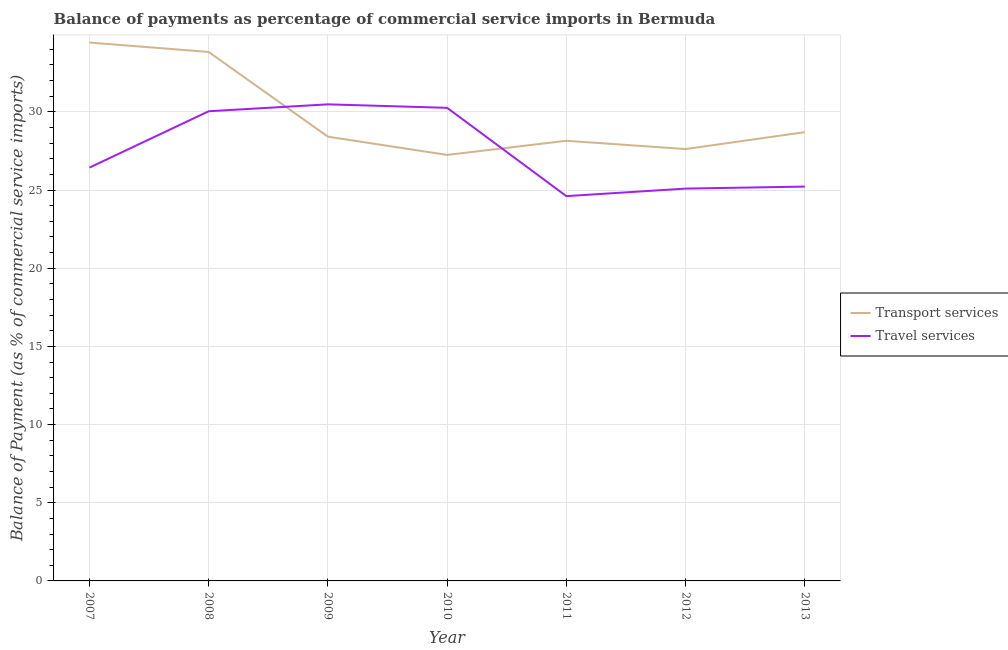What is the balance of payments of transport services in 2008?
Provide a short and direct response. 33.83. Across all years, what is the maximum balance of payments of travel services?
Ensure brevity in your answer.  30.48. Across all years, what is the minimum balance of payments of travel services?
Give a very brief answer. 24.61. In which year was the balance of payments of travel services maximum?
Offer a terse response. 2009. In which year was the balance of payments of transport services minimum?
Provide a short and direct response. 2010. What is the total balance of payments of transport services in the graph?
Provide a short and direct response. 208.41. What is the difference between the balance of payments of travel services in 2007 and that in 2012?
Your response must be concise. 1.34. What is the difference between the balance of payments of travel services in 2010 and the balance of payments of transport services in 2011?
Your answer should be very brief. 2.11. What is the average balance of payments of transport services per year?
Offer a very short reply. 29.77. In the year 2011, what is the difference between the balance of payments of transport services and balance of payments of travel services?
Your answer should be compact. 3.54. What is the ratio of the balance of payments of travel services in 2008 to that in 2009?
Your answer should be compact. 0.99. What is the difference between the highest and the second highest balance of payments of transport services?
Provide a succinct answer. 0.6. What is the difference between the highest and the lowest balance of payments of transport services?
Provide a short and direct response. 7.19. In how many years, is the balance of payments of travel services greater than the average balance of payments of travel services taken over all years?
Provide a succinct answer. 3. Does the balance of payments of travel services monotonically increase over the years?
Make the answer very short. No. What is the difference between two consecutive major ticks on the Y-axis?
Your answer should be compact. 5. Are the values on the major ticks of Y-axis written in scientific E-notation?
Offer a very short reply. No. Does the graph contain any zero values?
Make the answer very short. No. What is the title of the graph?
Provide a succinct answer. Balance of payments as percentage of commercial service imports in Bermuda. Does "Passenger Transport Items" appear as one of the legend labels in the graph?
Ensure brevity in your answer.  No. What is the label or title of the Y-axis?
Provide a short and direct response. Balance of Payment (as % of commercial service imports). What is the Balance of Payment (as % of commercial service imports) in Transport services in 2007?
Your answer should be very brief. 34.44. What is the Balance of Payment (as % of commercial service imports) of Travel services in 2007?
Offer a very short reply. 26.44. What is the Balance of Payment (as % of commercial service imports) of Transport services in 2008?
Your answer should be compact. 33.83. What is the Balance of Payment (as % of commercial service imports) of Travel services in 2008?
Your answer should be very brief. 30.04. What is the Balance of Payment (as % of commercial service imports) in Transport services in 2009?
Offer a terse response. 28.41. What is the Balance of Payment (as % of commercial service imports) in Travel services in 2009?
Ensure brevity in your answer.  30.48. What is the Balance of Payment (as % of commercial service imports) in Transport services in 2010?
Keep it short and to the point. 27.25. What is the Balance of Payment (as % of commercial service imports) in Travel services in 2010?
Provide a short and direct response. 30.26. What is the Balance of Payment (as % of commercial service imports) in Transport services in 2011?
Keep it short and to the point. 28.15. What is the Balance of Payment (as % of commercial service imports) in Travel services in 2011?
Your answer should be very brief. 24.61. What is the Balance of Payment (as % of commercial service imports) in Transport services in 2012?
Provide a short and direct response. 27.62. What is the Balance of Payment (as % of commercial service imports) in Travel services in 2012?
Make the answer very short. 25.09. What is the Balance of Payment (as % of commercial service imports) of Transport services in 2013?
Offer a terse response. 28.7. What is the Balance of Payment (as % of commercial service imports) of Travel services in 2013?
Your answer should be very brief. 25.22. Across all years, what is the maximum Balance of Payment (as % of commercial service imports) of Transport services?
Offer a terse response. 34.44. Across all years, what is the maximum Balance of Payment (as % of commercial service imports) in Travel services?
Offer a terse response. 30.48. Across all years, what is the minimum Balance of Payment (as % of commercial service imports) of Transport services?
Your response must be concise. 27.25. Across all years, what is the minimum Balance of Payment (as % of commercial service imports) in Travel services?
Provide a short and direct response. 24.61. What is the total Balance of Payment (as % of commercial service imports) of Transport services in the graph?
Your answer should be compact. 208.41. What is the total Balance of Payment (as % of commercial service imports) in Travel services in the graph?
Provide a short and direct response. 192.15. What is the difference between the Balance of Payment (as % of commercial service imports) of Transport services in 2007 and that in 2008?
Keep it short and to the point. 0.6. What is the difference between the Balance of Payment (as % of commercial service imports) in Travel services in 2007 and that in 2008?
Make the answer very short. -3.6. What is the difference between the Balance of Payment (as % of commercial service imports) of Transport services in 2007 and that in 2009?
Provide a short and direct response. 6.02. What is the difference between the Balance of Payment (as % of commercial service imports) in Travel services in 2007 and that in 2009?
Provide a succinct answer. -4.05. What is the difference between the Balance of Payment (as % of commercial service imports) in Transport services in 2007 and that in 2010?
Give a very brief answer. 7.19. What is the difference between the Balance of Payment (as % of commercial service imports) in Travel services in 2007 and that in 2010?
Provide a short and direct response. -3.82. What is the difference between the Balance of Payment (as % of commercial service imports) of Transport services in 2007 and that in 2011?
Your response must be concise. 6.28. What is the difference between the Balance of Payment (as % of commercial service imports) in Travel services in 2007 and that in 2011?
Ensure brevity in your answer.  1.82. What is the difference between the Balance of Payment (as % of commercial service imports) in Transport services in 2007 and that in 2012?
Make the answer very short. 6.81. What is the difference between the Balance of Payment (as % of commercial service imports) of Travel services in 2007 and that in 2012?
Your response must be concise. 1.34. What is the difference between the Balance of Payment (as % of commercial service imports) in Transport services in 2007 and that in 2013?
Offer a terse response. 5.73. What is the difference between the Balance of Payment (as % of commercial service imports) of Travel services in 2007 and that in 2013?
Keep it short and to the point. 1.22. What is the difference between the Balance of Payment (as % of commercial service imports) of Transport services in 2008 and that in 2009?
Your response must be concise. 5.42. What is the difference between the Balance of Payment (as % of commercial service imports) of Travel services in 2008 and that in 2009?
Offer a terse response. -0.44. What is the difference between the Balance of Payment (as % of commercial service imports) in Transport services in 2008 and that in 2010?
Offer a very short reply. 6.58. What is the difference between the Balance of Payment (as % of commercial service imports) of Travel services in 2008 and that in 2010?
Your answer should be very brief. -0.22. What is the difference between the Balance of Payment (as % of commercial service imports) of Transport services in 2008 and that in 2011?
Offer a terse response. 5.68. What is the difference between the Balance of Payment (as % of commercial service imports) of Travel services in 2008 and that in 2011?
Ensure brevity in your answer.  5.43. What is the difference between the Balance of Payment (as % of commercial service imports) of Transport services in 2008 and that in 2012?
Make the answer very short. 6.21. What is the difference between the Balance of Payment (as % of commercial service imports) in Travel services in 2008 and that in 2012?
Provide a short and direct response. 4.95. What is the difference between the Balance of Payment (as % of commercial service imports) in Transport services in 2008 and that in 2013?
Provide a succinct answer. 5.13. What is the difference between the Balance of Payment (as % of commercial service imports) in Travel services in 2008 and that in 2013?
Your answer should be compact. 4.82. What is the difference between the Balance of Payment (as % of commercial service imports) in Transport services in 2009 and that in 2010?
Provide a succinct answer. 1.17. What is the difference between the Balance of Payment (as % of commercial service imports) of Travel services in 2009 and that in 2010?
Give a very brief answer. 0.22. What is the difference between the Balance of Payment (as % of commercial service imports) of Transport services in 2009 and that in 2011?
Offer a terse response. 0.26. What is the difference between the Balance of Payment (as % of commercial service imports) of Travel services in 2009 and that in 2011?
Give a very brief answer. 5.87. What is the difference between the Balance of Payment (as % of commercial service imports) in Transport services in 2009 and that in 2012?
Make the answer very short. 0.79. What is the difference between the Balance of Payment (as % of commercial service imports) of Travel services in 2009 and that in 2012?
Offer a very short reply. 5.39. What is the difference between the Balance of Payment (as % of commercial service imports) in Transport services in 2009 and that in 2013?
Your response must be concise. -0.29. What is the difference between the Balance of Payment (as % of commercial service imports) in Travel services in 2009 and that in 2013?
Your answer should be very brief. 5.26. What is the difference between the Balance of Payment (as % of commercial service imports) in Transport services in 2010 and that in 2011?
Ensure brevity in your answer.  -0.9. What is the difference between the Balance of Payment (as % of commercial service imports) of Travel services in 2010 and that in 2011?
Offer a very short reply. 5.65. What is the difference between the Balance of Payment (as % of commercial service imports) in Transport services in 2010 and that in 2012?
Make the answer very short. -0.37. What is the difference between the Balance of Payment (as % of commercial service imports) of Travel services in 2010 and that in 2012?
Your response must be concise. 5.17. What is the difference between the Balance of Payment (as % of commercial service imports) of Transport services in 2010 and that in 2013?
Offer a terse response. -1.45. What is the difference between the Balance of Payment (as % of commercial service imports) of Travel services in 2010 and that in 2013?
Offer a terse response. 5.04. What is the difference between the Balance of Payment (as % of commercial service imports) of Transport services in 2011 and that in 2012?
Give a very brief answer. 0.53. What is the difference between the Balance of Payment (as % of commercial service imports) of Travel services in 2011 and that in 2012?
Make the answer very short. -0.48. What is the difference between the Balance of Payment (as % of commercial service imports) in Transport services in 2011 and that in 2013?
Ensure brevity in your answer.  -0.55. What is the difference between the Balance of Payment (as % of commercial service imports) in Travel services in 2011 and that in 2013?
Your answer should be very brief. -0.61. What is the difference between the Balance of Payment (as % of commercial service imports) of Transport services in 2012 and that in 2013?
Your answer should be compact. -1.08. What is the difference between the Balance of Payment (as % of commercial service imports) of Travel services in 2012 and that in 2013?
Offer a terse response. -0.13. What is the difference between the Balance of Payment (as % of commercial service imports) in Transport services in 2007 and the Balance of Payment (as % of commercial service imports) in Travel services in 2008?
Your response must be concise. 4.39. What is the difference between the Balance of Payment (as % of commercial service imports) in Transport services in 2007 and the Balance of Payment (as % of commercial service imports) in Travel services in 2009?
Ensure brevity in your answer.  3.95. What is the difference between the Balance of Payment (as % of commercial service imports) in Transport services in 2007 and the Balance of Payment (as % of commercial service imports) in Travel services in 2010?
Offer a terse response. 4.17. What is the difference between the Balance of Payment (as % of commercial service imports) in Transport services in 2007 and the Balance of Payment (as % of commercial service imports) in Travel services in 2011?
Provide a succinct answer. 9.82. What is the difference between the Balance of Payment (as % of commercial service imports) of Transport services in 2007 and the Balance of Payment (as % of commercial service imports) of Travel services in 2012?
Offer a terse response. 9.34. What is the difference between the Balance of Payment (as % of commercial service imports) of Transport services in 2007 and the Balance of Payment (as % of commercial service imports) of Travel services in 2013?
Make the answer very short. 9.21. What is the difference between the Balance of Payment (as % of commercial service imports) in Transport services in 2008 and the Balance of Payment (as % of commercial service imports) in Travel services in 2009?
Provide a short and direct response. 3.35. What is the difference between the Balance of Payment (as % of commercial service imports) in Transport services in 2008 and the Balance of Payment (as % of commercial service imports) in Travel services in 2010?
Make the answer very short. 3.57. What is the difference between the Balance of Payment (as % of commercial service imports) of Transport services in 2008 and the Balance of Payment (as % of commercial service imports) of Travel services in 2011?
Offer a terse response. 9.22. What is the difference between the Balance of Payment (as % of commercial service imports) of Transport services in 2008 and the Balance of Payment (as % of commercial service imports) of Travel services in 2012?
Ensure brevity in your answer.  8.74. What is the difference between the Balance of Payment (as % of commercial service imports) in Transport services in 2008 and the Balance of Payment (as % of commercial service imports) in Travel services in 2013?
Your answer should be very brief. 8.61. What is the difference between the Balance of Payment (as % of commercial service imports) in Transport services in 2009 and the Balance of Payment (as % of commercial service imports) in Travel services in 2010?
Offer a very short reply. -1.85. What is the difference between the Balance of Payment (as % of commercial service imports) of Transport services in 2009 and the Balance of Payment (as % of commercial service imports) of Travel services in 2011?
Make the answer very short. 3.8. What is the difference between the Balance of Payment (as % of commercial service imports) of Transport services in 2009 and the Balance of Payment (as % of commercial service imports) of Travel services in 2012?
Keep it short and to the point. 3.32. What is the difference between the Balance of Payment (as % of commercial service imports) in Transport services in 2009 and the Balance of Payment (as % of commercial service imports) in Travel services in 2013?
Offer a very short reply. 3.19. What is the difference between the Balance of Payment (as % of commercial service imports) of Transport services in 2010 and the Balance of Payment (as % of commercial service imports) of Travel services in 2011?
Ensure brevity in your answer.  2.64. What is the difference between the Balance of Payment (as % of commercial service imports) of Transport services in 2010 and the Balance of Payment (as % of commercial service imports) of Travel services in 2012?
Make the answer very short. 2.15. What is the difference between the Balance of Payment (as % of commercial service imports) in Transport services in 2010 and the Balance of Payment (as % of commercial service imports) in Travel services in 2013?
Offer a very short reply. 2.03. What is the difference between the Balance of Payment (as % of commercial service imports) of Transport services in 2011 and the Balance of Payment (as % of commercial service imports) of Travel services in 2012?
Keep it short and to the point. 3.06. What is the difference between the Balance of Payment (as % of commercial service imports) of Transport services in 2011 and the Balance of Payment (as % of commercial service imports) of Travel services in 2013?
Give a very brief answer. 2.93. What is the difference between the Balance of Payment (as % of commercial service imports) in Transport services in 2012 and the Balance of Payment (as % of commercial service imports) in Travel services in 2013?
Provide a short and direct response. 2.4. What is the average Balance of Payment (as % of commercial service imports) of Transport services per year?
Keep it short and to the point. 29.77. What is the average Balance of Payment (as % of commercial service imports) in Travel services per year?
Offer a very short reply. 27.45. In the year 2007, what is the difference between the Balance of Payment (as % of commercial service imports) of Transport services and Balance of Payment (as % of commercial service imports) of Travel services?
Your answer should be very brief. 8. In the year 2008, what is the difference between the Balance of Payment (as % of commercial service imports) in Transport services and Balance of Payment (as % of commercial service imports) in Travel services?
Keep it short and to the point. 3.79. In the year 2009, what is the difference between the Balance of Payment (as % of commercial service imports) in Transport services and Balance of Payment (as % of commercial service imports) in Travel services?
Offer a very short reply. -2.07. In the year 2010, what is the difference between the Balance of Payment (as % of commercial service imports) of Transport services and Balance of Payment (as % of commercial service imports) of Travel services?
Offer a terse response. -3.01. In the year 2011, what is the difference between the Balance of Payment (as % of commercial service imports) in Transport services and Balance of Payment (as % of commercial service imports) in Travel services?
Keep it short and to the point. 3.54. In the year 2012, what is the difference between the Balance of Payment (as % of commercial service imports) in Transport services and Balance of Payment (as % of commercial service imports) in Travel services?
Keep it short and to the point. 2.53. In the year 2013, what is the difference between the Balance of Payment (as % of commercial service imports) of Transport services and Balance of Payment (as % of commercial service imports) of Travel services?
Offer a terse response. 3.48. What is the ratio of the Balance of Payment (as % of commercial service imports) in Transport services in 2007 to that in 2008?
Your response must be concise. 1.02. What is the ratio of the Balance of Payment (as % of commercial service imports) in Travel services in 2007 to that in 2008?
Ensure brevity in your answer.  0.88. What is the ratio of the Balance of Payment (as % of commercial service imports) of Transport services in 2007 to that in 2009?
Provide a short and direct response. 1.21. What is the ratio of the Balance of Payment (as % of commercial service imports) in Travel services in 2007 to that in 2009?
Ensure brevity in your answer.  0.87. What is the ratio of the Balance of Payment (as % of commercial service imports) of Transport services in 2007 to that in 2010?
Your response must be concise. 1.26. What is the ratio of the Balance of Payment (as % of commercial service imports) in Travel services in 2007 to that in 2010?
Provide a short and direct response. 0.87. What is the ratio of the Balance of Payment (as % of commercial service imports) in Transport services in 2007 to that in 2011?
Offer a very short reply. 1.22. What is the ratio of the Balance of Payment (as % of commercial service imports) in Travel services in 2007 to that in 2011?
Offer a very short reply. 1.07. What is the ratio of the Balance of Payment (as % of commercial service imports) of Transport services in 2007 to that in 2012?
Keep it short and to the point. 1.25. What is the ratio of the Balance of Payment (as % of commercial service imports) in Travel services in 2007 to that in 2012?
Your response must be concise. 1.05. What is the ratio of the Balance of Payment (as % of commercial service imports) of Transport services in 2007 to that in 2013?
Ensure brevity in your answer.  1.2. What is the ratio of the Balance of Payment (as % of commercial service imports) in Travel services in 2007 to that in 2013?
Your response must be concise. 1.05. What is the ratio of the Balance of Payment (as % of commercial service imports) in Transport services in 2008 to that in 2009?
Your answer should be very brief. 1.19. What is the ratio of the Balance of Payment (as % of commercial service imports) of Travel services in 2008 to that in 2009?
Your response must be concise. 0.99. What is the ratio of the Balance of Payment (as % of commercial service imports) of Transport services in 2008 to that in 2010?
Give a very brief answer. 1.24. What is the ratio of the Balance of Payment (as % of commercial service imports) in Travel services in 2008 to that in 2010?
Your answer should be compact. 0.99. What is the ratio of the Balance of Payment (as % of commercial service imports) in Transport services in 2008 to that in 2011?
Make the answer very short. 1.2. What is the ratio of the Balance of Payment (as % of commercial service imports) of Travel services in 2008 to that in 2011?
Provide a succinct answer. 1.22. What is the ratio of the Balance of Payment (as % of commercial service imports) in Transport services in 2008 to that in 2012?
Offer a terse response. 1.22. What is the ratio of the Balance of Payment (as % of commercial service imports) of Travel services in 2008 to that in 2012?
Your answer should be very brief. 1.2. What is the ratio of the Balance of Payment (as % of commercial service imports) of Transport services in 2008 to that in 2013?
Keep it short and to the point. 1.18. What is the ratio of the Balance of Payment (as % of commercial service imports) in Travel services in 2008 to that in 2013?
Offer a very short reply. 1.19. What is the ratio of the Balance of Payment (as % of commercial service imports) of Transport services in 2009 to that in 2010?
Provide a succinct answer. 1.04. What is the ratio of the Balance of Payment (as % of commercial service imports) of Travel services in 2009 to that in 2010?
Provide a short and direct response. 1.01. What is the ratio of the Balance of Payment (as % of commercial service imports) of Transport services in 2009 to that in 2011?
Offer a very short reply. 1.01. What is the ratio of the Balance of Payment (as % of commercial service imports) of Travel services in 2009 to that in 2011?
Your answer should be very brief. 1.24. What is the ratio of the Balance of Payment (as % of commercial service imports) in Transport services in 2009 to that in 2012?
Your answer should be very brief. 1.03. What is the ratio of the Balance of Payment (as % of commercial service imports) in Travel services in 2009 to that in 2012?
Your response must be concise. 1.21. What is the ratio of the Balance of Payment (as % of commercial service imports) in Travel services in 2009 to that in 2013?
Give a very brief answer. 1.21. What is the ratio of the Balance of Payment (as % of commercial service imports) of Transport services in 2010 to that in 2011?
Offer a terse response. 0.97. What is the ratio of the Balance of Payment (as % of commercial service imports) in Travel services in 2010 to that in 2011?
Offer a terse response. 1.23. What is the ratio of the Balance of Payment (as % of commercial service imports) of Transport services in 2010 to that in 2012?
Your answer should be compact. 0.99. What is the ratio of the Balance of Payment (as % of commercial service imports) in Travel services in 2010 to that in 2012?
Make the answer very short. 1.21. What is the ratio of the Balance of Payment (as % of commercial service imports) in Transport services in 2010 to that in 2013?
Provide a short and direct response. 0.95. What is the ratio of the Balance of Payment (as % of commercial service imports) of Travel services in 2010 to that in 2013?
Ensure brevity in your answer.  1.2. What is the ratio of the Balance of Payment (as % of commercial service imports) in Transport services in 2011 to that in 2012?
Provide a short and direct response. 1.02. What is the ratio of the Balance of Payment (as % of commercial service imports) of Travel services in 2011 to that in 2012?
Ensure brevity in your answer.  0.98. What is the ratio of the Balance of Payment (as % of commercial service imports) in Transport services in 2011 to that in 2013?
Ensure brevity in your answer.  0.98. What is the ratio of the Balance of Payment (as % of commercial service imports) in Travel services in 2011 to that in 2013?
Ensure brevity in your answer.  0.98. What is the ratio of the Balance of Payment (as % of commercial service imports) of Transport services in 2012 to that in 2013?
Offer a terse response. 0.96. What is the ratio of the Balance of Payment (as % of commercial service imports) of Travel services in 2012 to that in 2013?
Offer a very short reply. 0.99. What is the difference between the highest and the second highest Balance of Payment (as % of commercial service imports) of Transport services?
Provide a succinct answer. 0.6. What is the difference between the highest and the second highest Balance of Payment (as % of commercial service imports) in Travel services?
Offer a terse response. 0.22. What is the difference between the highest and the lowest Balance of Payment (as % of commercial service imports) in Transport services?
Provide a succinct answer. 7.19. What is the difference between the highest and the lowest Balance of Payment (as % of commercial service imports) of Travel services?
Your answer should be very brief. 5.87. 